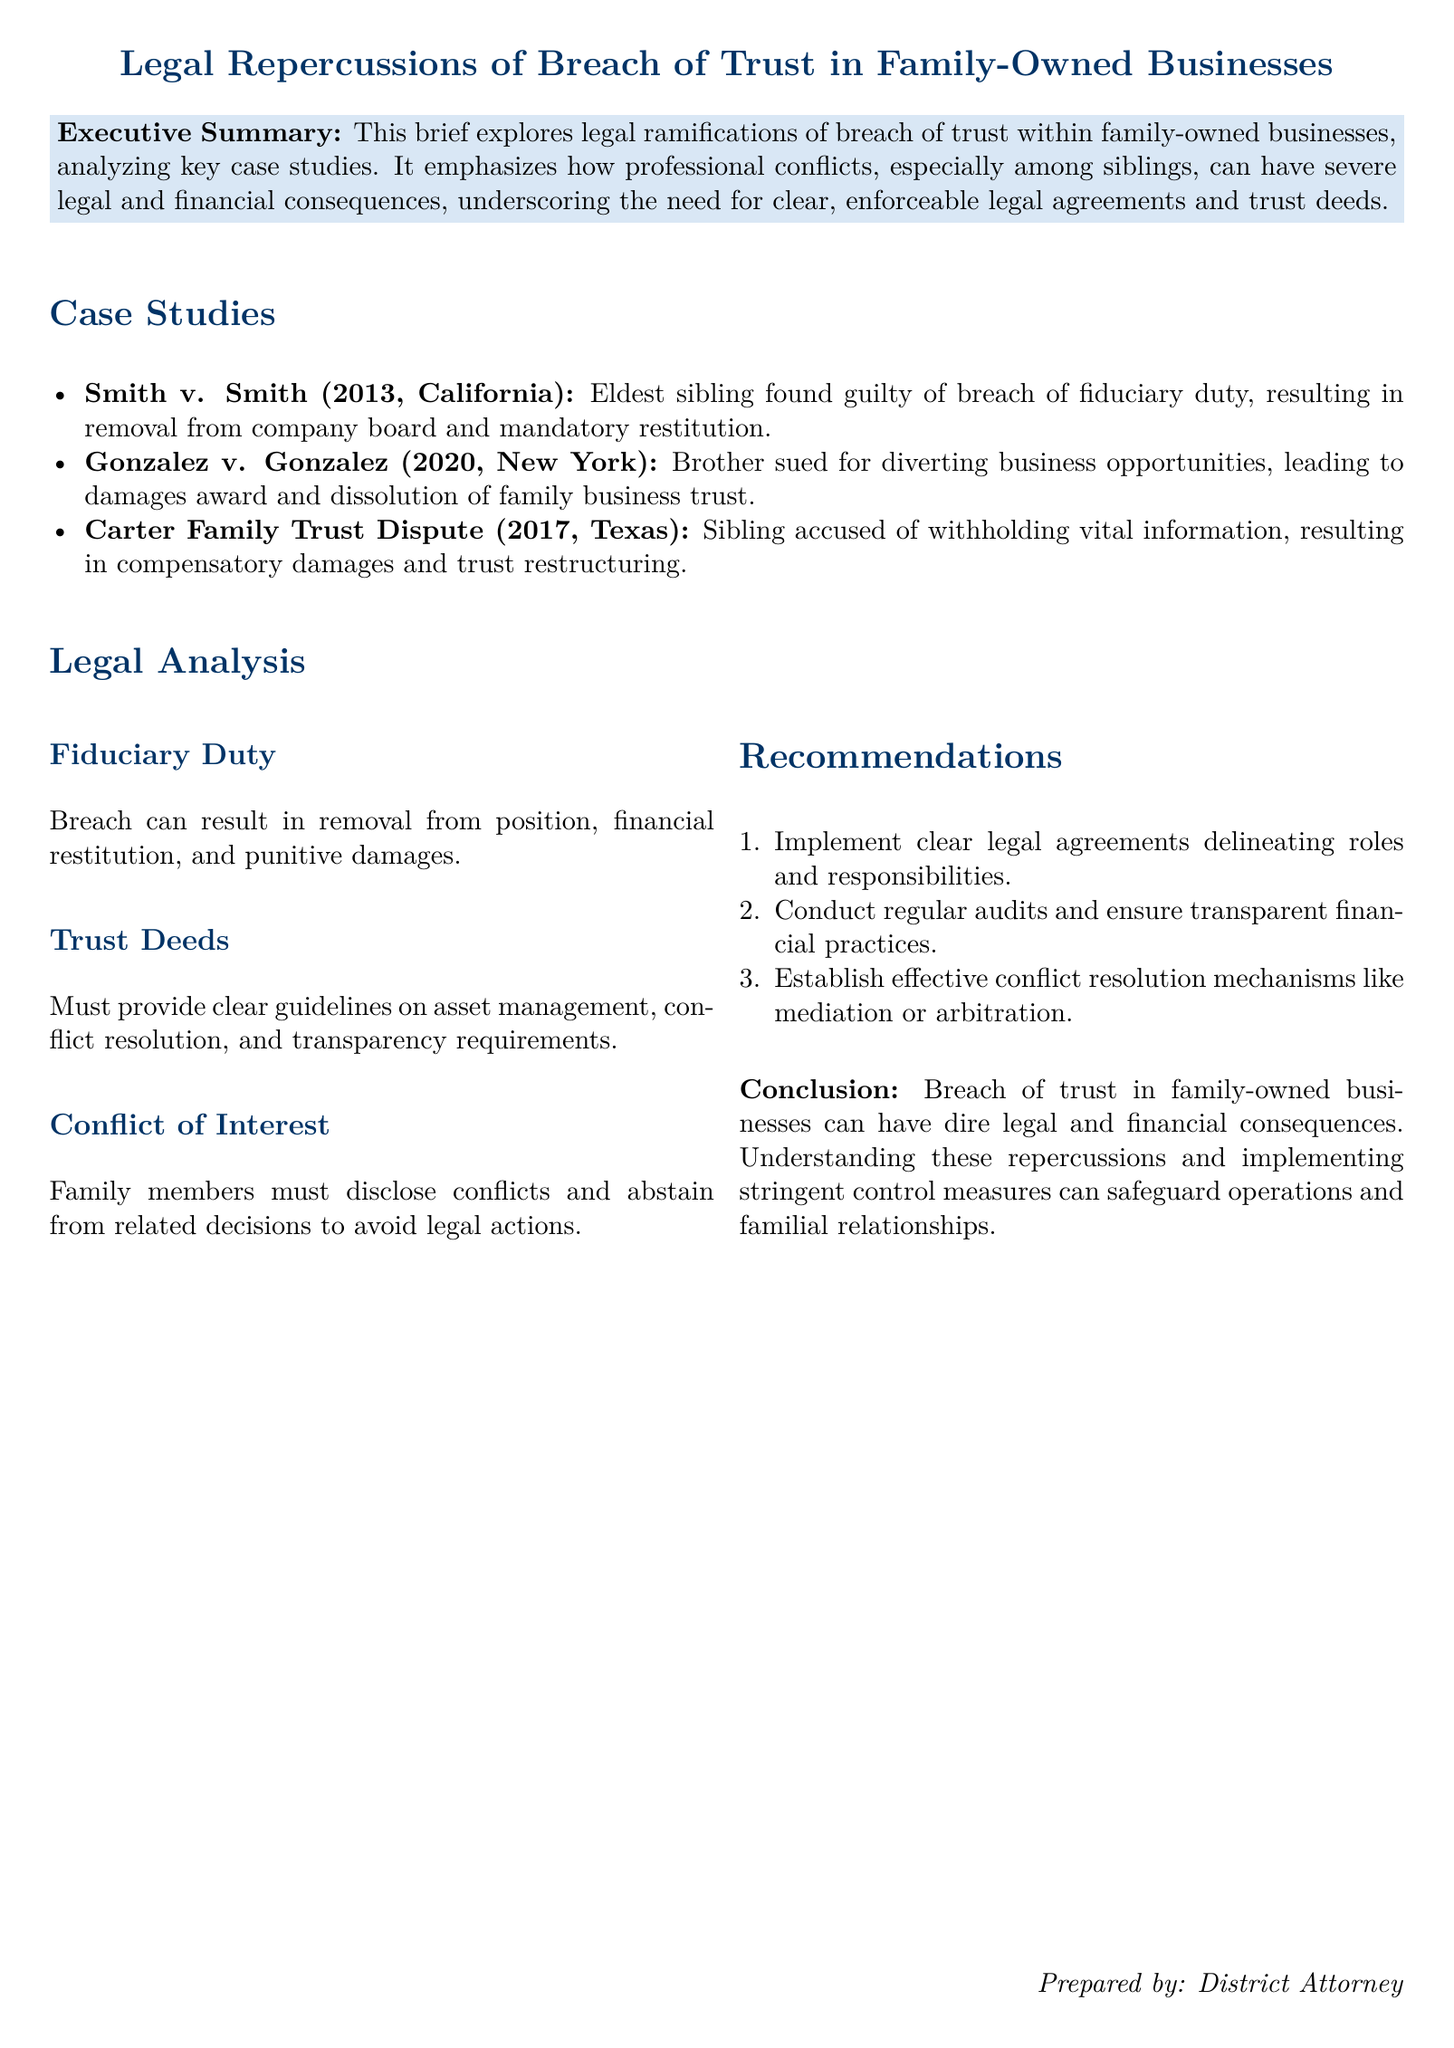What is the title of the document? The title is clearly stated at the beginning of the document, which is "Legal Repercussions of Breach of Trust in Family-Owned Businesses."
Answer: Legal Repercussions of Breach of Trust in Family-Owned Businesses What is the case year for Smith v. Smith? The case year is mentioned in the case study section for Smith v. Smith.
Answer: 2013 Who was found guilty in Smith v. Smith? The brief specifies that the eldest sibling was found guilty of breach of fiduciary duty.
Answer: Eldest sibling What legal consequence resulted from Gonzalez v. Gonzalez? The brief indicates that Gonzalez v. Gonzalez led to a damages award and the dissolution of the family business trust.
Answer: Damages award and dissolution What should trust deeds provide according to the legal analysis? The document states that trust deeds must provide clear guidelines on asset management, conflict resolution, and transparency requirements.
Answer: Clear guidelines on asset management, conflict resolution, and transparency requirements What is one recommendation made in the document? The document lists several recommendations, one of which is to implement clear legal agreements delineating roles and responsibilities.
Answer: Implement clear legal agreements delineating roles and responsibilities How many case studies are presented in the document? The case studies section lists three notable cases discussed in the brief.
Answer: Three What can a breach of trust in family-owned businesses lead to? The conclusion summarizes that a breach of trust can have dire legal and financial consequences.
Answer: Dire legal and financial consequences What role does the document suggest family members play regarding conflicts of interest? The legal analysis emphasizes that family members must disclose conflicts and abstain from related decisions.
Answer: Disclose conflicts and abstain from related decisions 